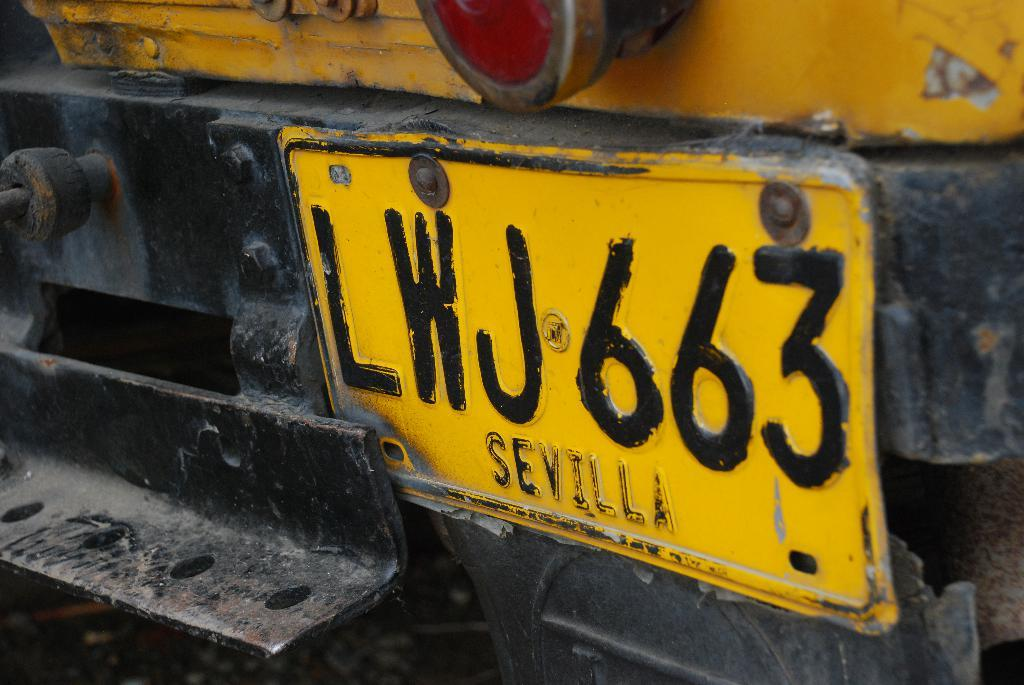<image>
Relay a brief, clear account of the picture shown. A license plate with the number LWJ663 says Sevilla at the bottom. 